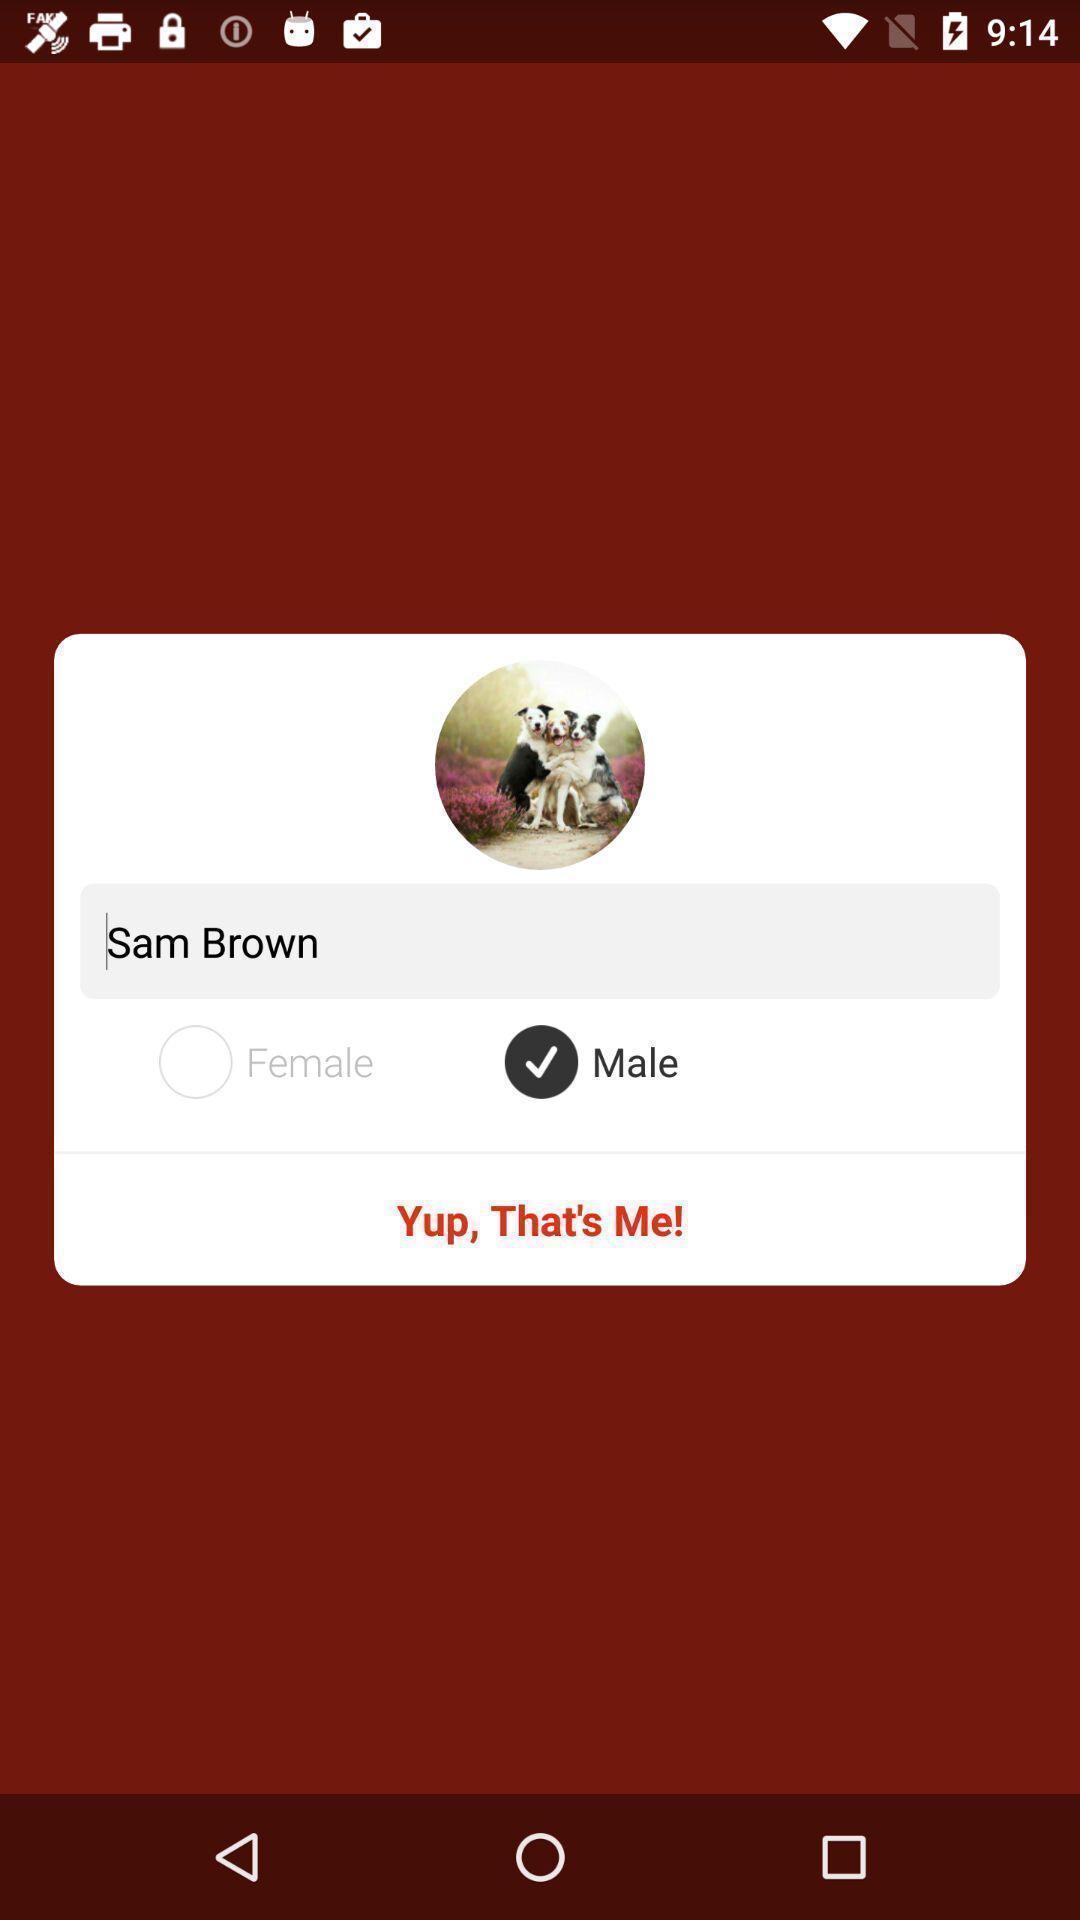What can you discern from this picture? Pop up with gender option. 